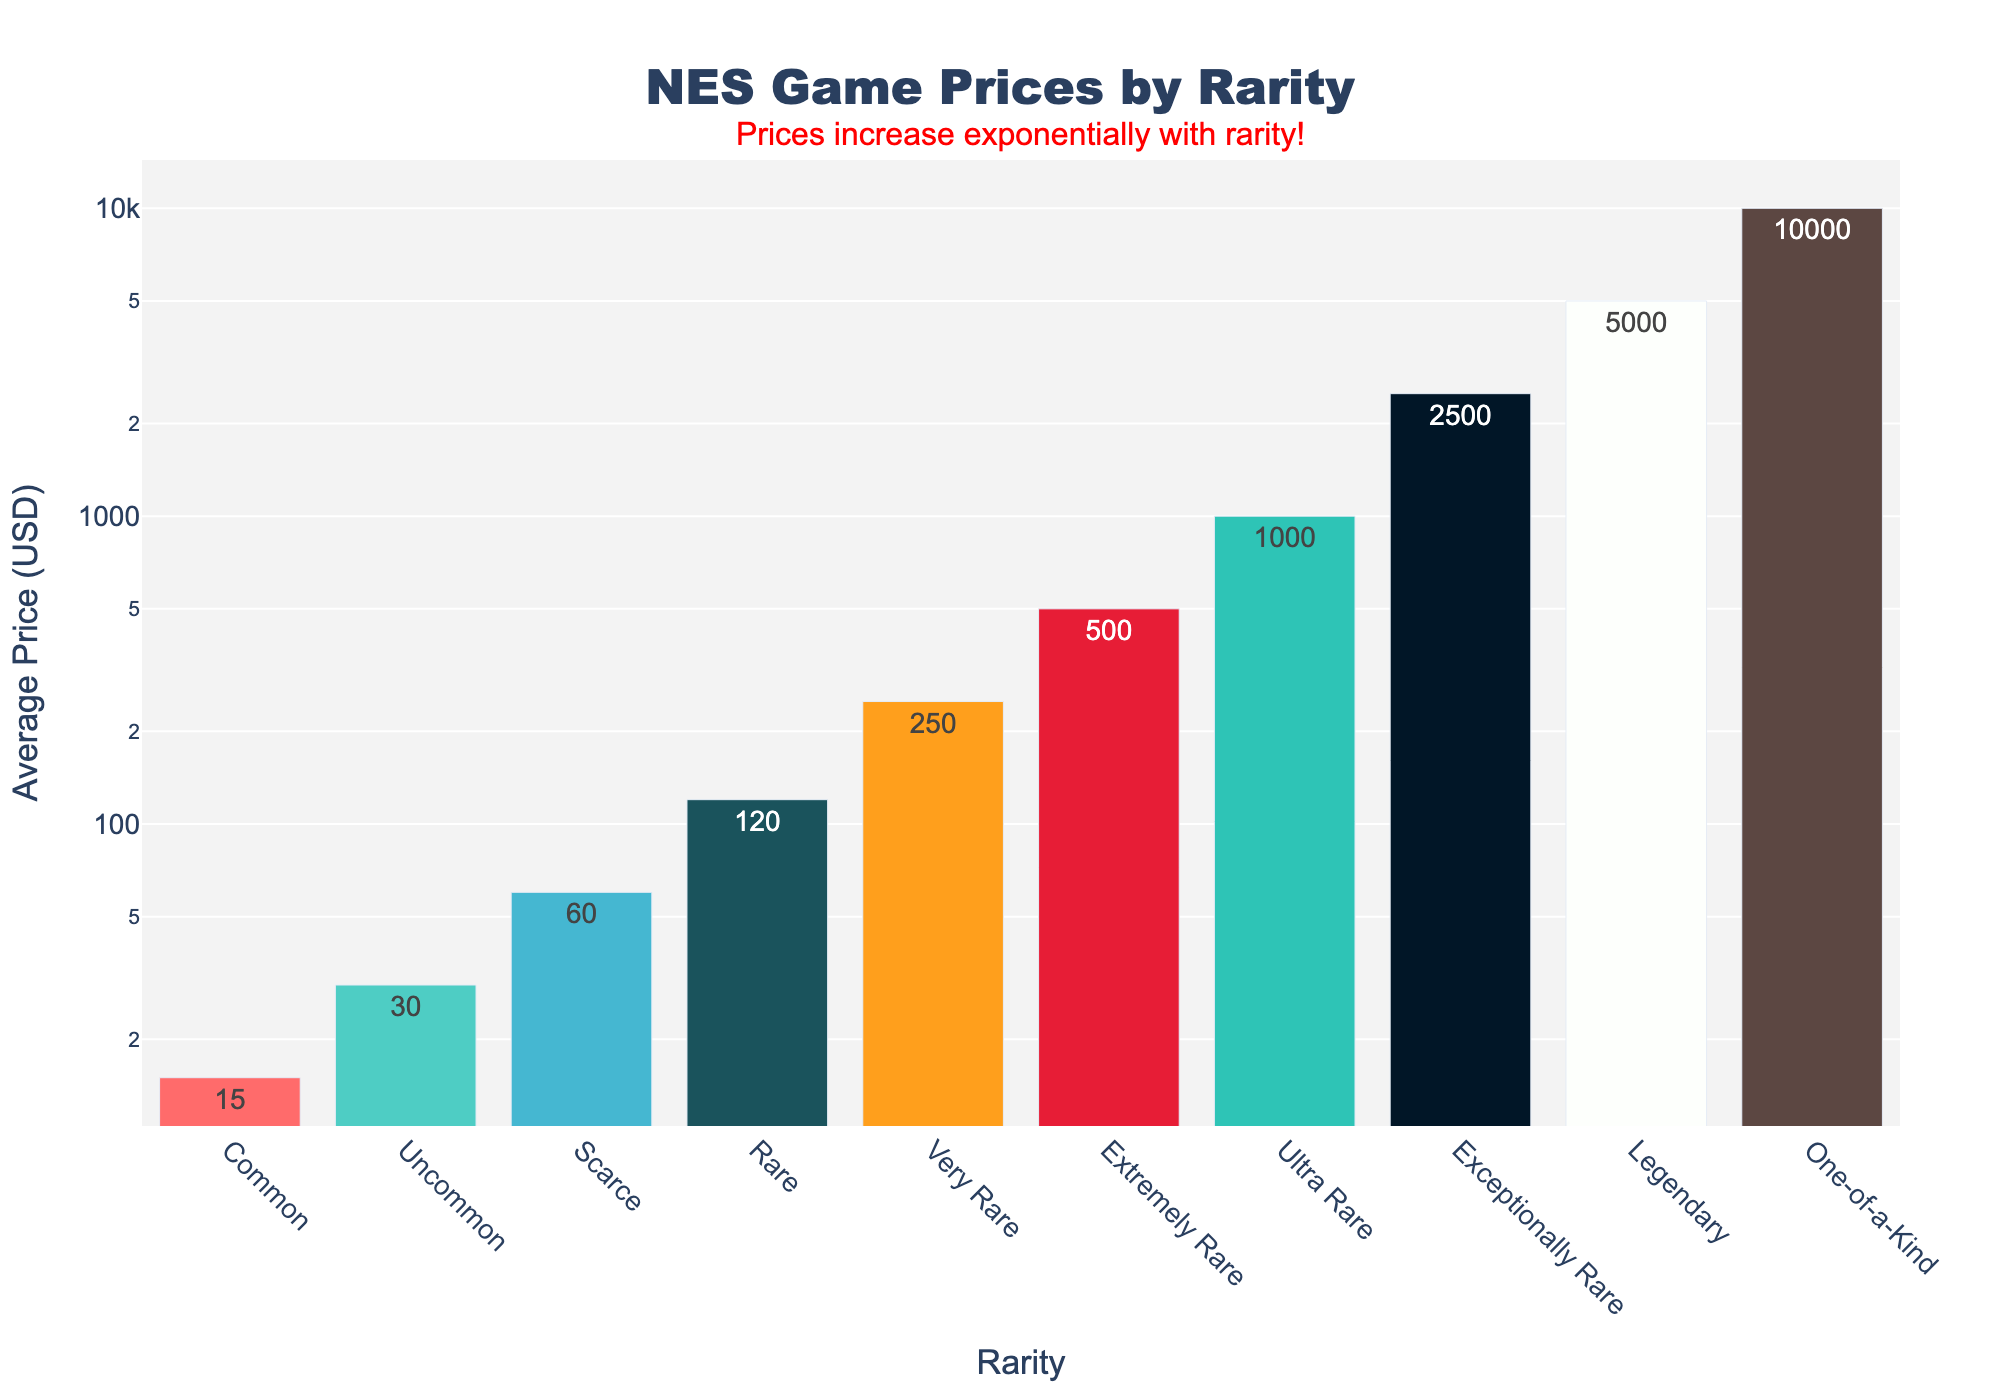What's the most expensive NES game rarity category? The bar chart clearly shows the highest value of $10,000 under the "One-of-a-Kind" category, which is taller than the rest.
Answer: One-of-a-Kind How much more expensive are Ultra Rare games compared to Common games? The average price for Ultra Rare games is $1,000 and for Common games is $15. Therefore, the price difference is $1,000 - $15 = $985.
Answer: $985 Which category has a price of $250? By looking at the bar chart, the "Very Rare" category has an average price of $250.
Answer: Very Rare What is the median price among the listed rarities? To find the median price, list the prices in order: $15, $30, $60, $120, $250, $500, $1,000, $2,500, $5,000, $10,000. The median value, being the middle number of this sorted list, is $250.
Answer: $250 Are Rare games priced closer to Uncommon or Very Rare games? The average price for Rare games is $120, for Uncommon games is $30, and for Very Rare games is $250. The difference between Rare and Uncommon is $120 - $30 = $90, and between Rare and Very Rare it is $250 - $120 = $130. Hence, Rare games are priced closer to Uncommon.
Answer: Uncommon Which bar is the tallest in the chart? The “One-of-a-Kind” bar is visually the tallest and represents the highest price of $10,000.
Answer: One-of-a-Kind What is the visual pattern in the price change with respect to rarity? The bars increase in height as the rarity increases, suggesting that prices rise exponentially with the rarity of the games.
Answer: Prices rise exponentially How much do Scarce and Extremely Rare games cost together? The average price for Scarce games is $60 and for Extremely Rare games is $500. Adding these prices gives $60 + $500 = $560.
Answer: $560 Which color represents the Rare category in the bar chart? The Rare category, having an average price of $120, is represented by the fourth bar from the left, which is colored dark green.
Answer: Dark green 